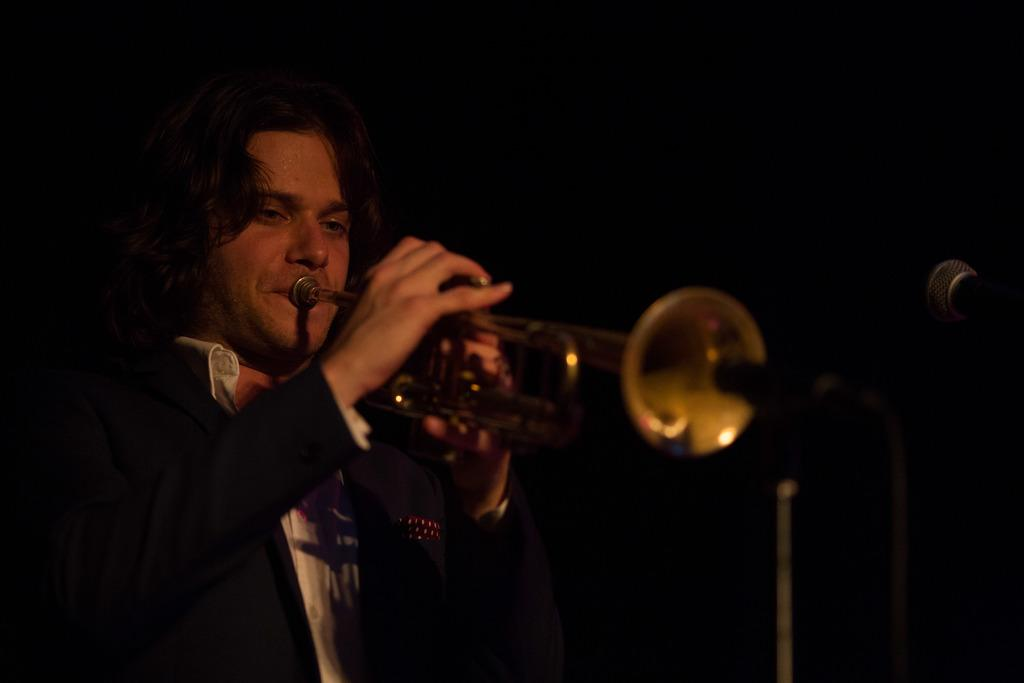What is the main subject of the image? The main subject of the image is a man. What is the man doing in the image? The man is playing a music instrument in the image. What type of destruction is the man causing in the image? There is no destruction present in the image; the man is playing a music instrument. How many family members can be seen in the image? There is no family member present in the image; only the man playing the music instrument is visible. 